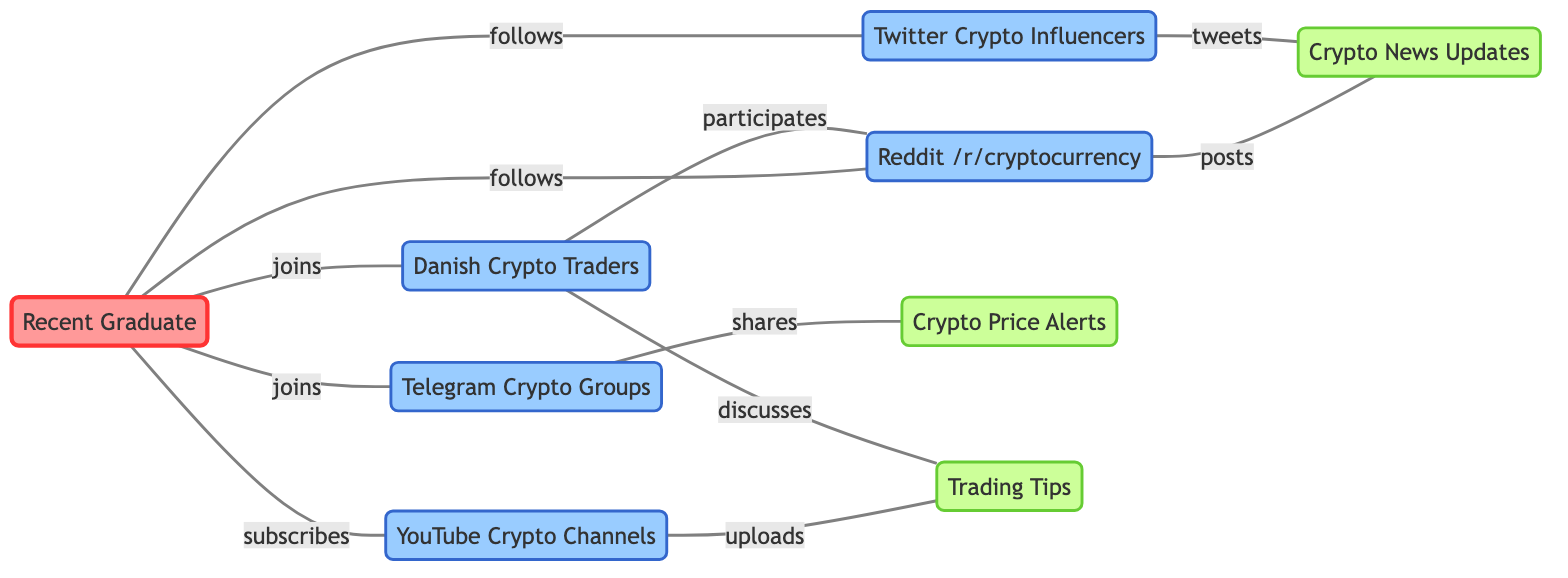What are the total number of nodes in the diagram? The diagram contains 9 nodes related to cryptocurrency communities and their interactions.
Answer: 9 Which platform does the recent graduate join? The recent graduate is connected to the Telegram Crypto Groups and Danish Crypto Traders, indicating their participation in these platforms.
Answer: Telegram Crypto Groups, Danish Crypto Traders How many edges are connected to the YouTube Crypto Channels? The YouTube Crypto Channels node has one outgoing edge connecting it to Trading Tips, indicating a single relationship for uploads.
Answer: 1 What relationship does Reddit /r/cryptocurrency have with Crypto News Updates? The Reddit /r/cryptocurrency node posts to the Crypto News Updates node, establishing a direct relationship.
Answer: posts Which social media platform shares price alerts? The Telegram Crypto Groups is the platform responsible for sharing price alerts, as indicated by its connection to the Crypto Price Alerts node.
Answer: Telegram Crypto Groups In which activities does the Danish Crypto Traders participate? The Danish Crypto Traders participates in both Reddit and discusses Trading Tips, showing their engagement in community discussions across platforms.
Answer: participates, discusses Which node has the most connections to other nodes? The recent graduate has connections to five different platforms, making it the most interconnected node in the diagram.
Answer: Recent Graduate What kind of content does YouTube Crypto Channels upload? YouTube Crypto Channels uploads Trading Tips, indicating the type of content shared from this platform.
Answer: Trading Tips How many platforms does the recent graduate follow? The recent graduate follows two platforms: Reddit /r/cryptocurrency and Twitter Crypto Influencers, indicating their engagement in those communities.
Answer: 2 